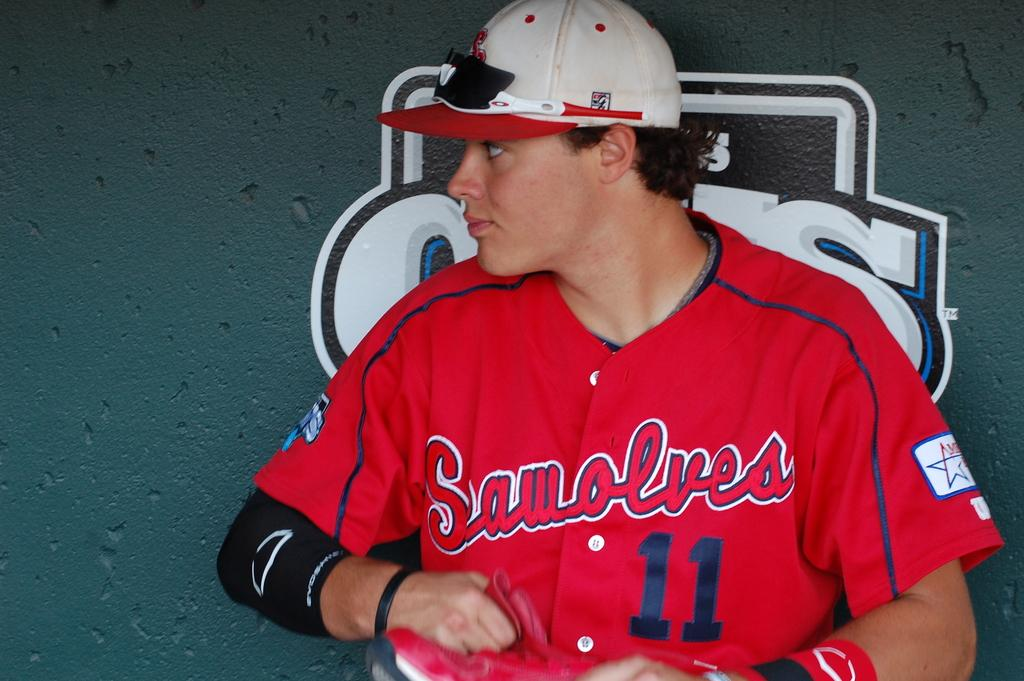<image>
Write a terse but informative summary of the picture. A young man in a baseball jersey for the Sawolves, #11. 